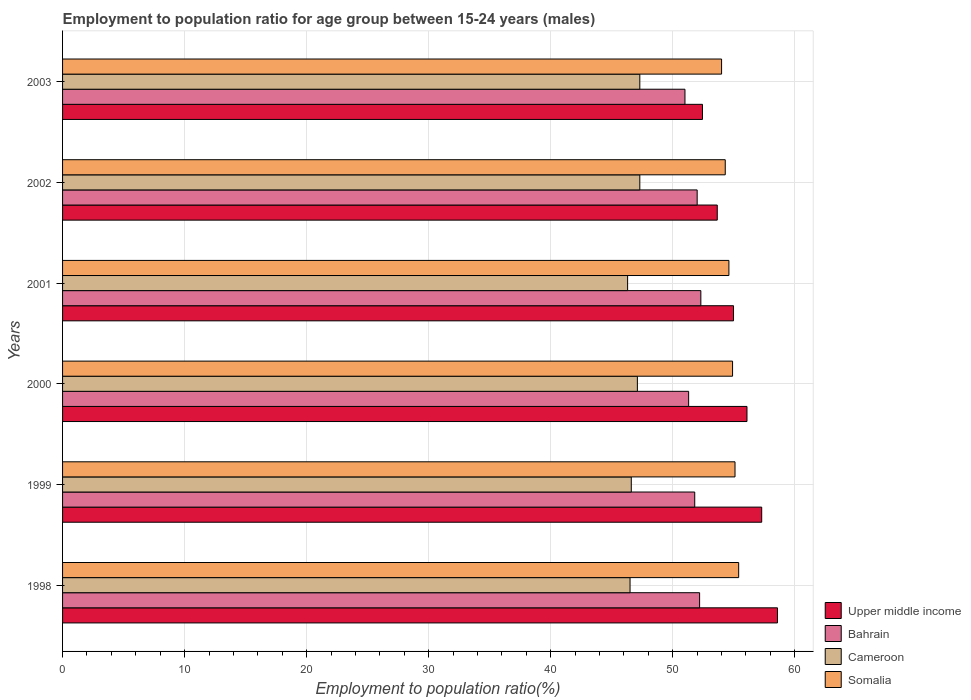How many different coloured bars are there?
Provide a short and direct response. 4. How many groups of bars are there?
Ensure brevity in your answer.  6. Are the number of bars per tick equal to the number of legend labels?
Your answer should be very brief. Yes. Are the number of bars on each tick of the Y-axis equal?
Your response must be concise. Yes. How many bars are there on the 6th tick from the bottom?
Give a very brief answer. 4. Across all years, what is the maximum employment to population ratio in Upper middle income?
Make the answer very short. 58.58. Across all years, what is the minimum employment to population ratio in Cameroon?
Offer a terse response. 46.3. In which year was the employment to population ratio in Somalia maximum?
Keep it short and to the point. 1998. What is the total employment to population ratio in Somalia in the graph?
Your answer should be compact. 328.3. What is the difference between the employment to population ratio in Upper middle income in 1998 and that in 1999?
Make the answer very short. 1.29. What is the difference between the employment to population ratio in Bahrain in 1998 and the employment to population ratio in Upper middle income in 1999?
Your answer should be compact. -5.09. What is the average employment to population ratio in Bahrain per year?
Make the answer very short. 51.77. What is the ratio of the employment to population ratio in Cameroon in 2000 to that in 2002?
Offer a very short reply. 1. Is the employment to population ratio in Bahrain in 1998 less than that in 2000?
Offer a terse response. No. Is the difference between the employment to population ratio in Somalia in 2001 and 2003 greater than the difference between the employment to population ratio in Bahrain in 2001 and 2003?
Offer a terse response. No. What is the difference between the highest and the second highest employment to population ratio in Somalia?
Offer a very short reply. 0.3. Is it the case that in every year, the sum of the employment to population ratio in Upper middle income and employment to population ratio in Cameroon is greater than the sum of employment to population ratio in Somalia and employment to population ratio in Bahrain?
Give a very brief answer. No. What does the 4th bar from the top in 2000 represents?
Offer a very short reply. Upper middle income. What does the 4th bar from the bottom in 2000 represents?
Your answer should be very brief. Somalia. Are all the bars in the graph horizontal?
Your response must be concise. Yes. How many years are there in the graph?
Your answer should be compact. 6. Are the values on the major ticks of X-axis written in scientific E-notation?
Keep it short and to the point. No. Does the graph contain any zero values?
Ensure brevity in your answer.  No. Does the graph contain grids?
Provide a succinct answer. Yes. Where does the legend appear in the graph?
Your answer should be compact. Bottom right. How many legend labels are there?
Provide a short and direct response. 4. What is the title of the graph?
Ensure brevity in your answer.  Employment to population ratio for age group between 15-24 years (males). What is the Employment to population ratio(%) in Upper middle income in 1998?
Provide a succinct answer. 58.58. What is the Employment to population ratio(%) in Bahrain in 1998?
Provide a succinct answer. 52.2. What is the Employment to population ratio(%) of Cameroon in 1998?
Your answer should be compact. 46.5. What is the Employment to population ratio(%) of Somalia in 1998?
Offer a very short reply. 55.4. What is the Employment to population ratio(%) in Upper middle income in 1999?
Offer a very short reply. 57.29. What is the Employment to population ratio(%) of Bahrain in 1999?
Offer a very short reply. 51.8. What is the Employment to population ratio(%) of Cameroon in 1999?
Make the answer very short. 46.6. What is the Employment to population ratio(%) of Somalia in 1999?
Your response must be concise. 55.1. What is the Employment to population ratio(%) in Upper middle income in 2000?
Offer a terse response. 56.08. What is the Employment to population ratio(%) in Bahrain in 2000?
Make the answer very short. 51.3. What is the Employment to population ratio(%) of Cameroon in 2000?
Keep it short and to the point. 47.1. What is the Employment to population ratio(%) of Somalia in 2000?
Your answer should be very brief. 54.9. What is the Employment to population ratio(%) in Upper middle income in 2001?
Your answer should be compact. 54.98. What is the Employment to population ratio(%) in Bahrain in 2001?
Offer a very short reply. 52.3. What is the Employment to population ratio(%) in Cameroon in 2001?
Offer a terse response. 46.3. What is the Employment to population ratio(%) of Somalia in 2001?
Offer a very short reply. 54.6. What is the Employment to population ratio(%) of Upper middle income in 2002?
Your answer should be very brief. 53.65. What is the Employment to population ratio(%) in Cameroon in 2002?
Your response must be concise. 47.3. What is the Employment to population ratio(%) of Somalia in 2002?
Provide a succinct answer. 54.3. What is the Employment to population ratio(%) of Upper middle income in 2003?
Offer a terse response. 52.43. What is the Employment to population ratio(%) in Cameroon in 2003?
Your answer should be very brief. 47.3. Across all years, what is the maximum Employment to population ratio(%) of Upper middle income?
Make the answer very short. 58.58. Across all years, what is the maximum Employment to population ratio(%) in Bahrain?
Provide a short and direct response. 52.3. Across all years, what is the maximum Employment to population ratio(%) in Cameroon?
Provide a short and direct response. 47.3. Across all years, what is the maximum Employment to population ratio(%) in Somalia?
Provide a succinct answer. 55.4. Across all years, what is the minimum Employment to population ratio(%) of Upper middle income?
Your answer should be compact. 52.43. Across all years, what is the minimum Employment to population ratio(%) in Bahrain?
Your response must be concise. 51. Across all years, what is the minimum Employment to population ratio(%) in Cameroon?
Provide a short and direct response. 46.3. What is the total Employment to population ratio(%) of Upper middle income in the graph?
Keep it short and to the point. 333.01. What is the total Employment to population ratio(%) of Bahrain in the graph?
Make the answer very short. 310.6. What is the total Employment to population ratio(%) of Cameroon in the graph?
Ensure brevity in your answer.  281.1. What is the total Employment to population ratio(%) of Somalia in the graph?
Offer a terse response. 328.3. What is the difference between the Employment to population ratio(%) of Upper middle income in 1998 and that in 1999?
Provide a succinct answer. 1.29. What is the difference between the Employment to population ratio(%) of Bahrain in 1998 and that in 1999?
Your response must be concise. 0.4. What is the difference between the Employment to population ratio(%) in Cameroon in 1998 and that in 1999?
Provide a short and direct response. -0.1. What is the difference between the Employment to population ratio(%) in Upper middle income in 1998 and that in 2000?
Make the answer very short. 2.5. What is the difference between the Employment to population ratio(%) in Bahrain in 1998 and that in 2000?
Provide a short and direct response. 0.9. What is the difference between the Employment to population ratio(%) of Upper middle income in 1998 and that in 2001?
Make the answer very short. 3.6. What is the difference between the Employment to population ratio(%) of Cameroon in 1998 and that in 2001?
Your answer should be very brief. 0.2. What is the difference between the Employment to population ratio(%) in Upper middle income in 1998 and that in 2002?
Make the answer very short. 4.93. What is the difference between the Employment to population ratio(%) in Bahrain in 1998 and that in 2002?
Offer a very short reply. 0.2. What is the difference between the Employment to population ratio(%) of Cameroon in 1998 and that in 2002?
Your answer should be very brief. -0.8. What is the difference between the Employment to population ratio(%) in Somalia in 1998 and that in 2002?
Provide a succinct answer. 1.1. What is the difference between the Employment to population ratio(%) of Upper middle income in 1998 and that in 2003?
Provide a succinct answer. 6.14. What is the difference between the Employment to population ratio(%) of Cameroon in 1998 and that in 2003?
Give a very brief answer. -0.8. What is the difference between the Employment to population ratio(%) of Somalia in 1998 and that in 2003?
Provide a short and direct response. 1.4. What is the difference between the Employment to population ratio(%) in Upper middle income in 1999 and that in 2000?
Keep it short and to the point. 1.21. What is the difference between the Employment to population ratio(%) in Cameroon in 1999 and that in 2000?
Your answer should be very brief. -0.5. What is the difference between the Employment to population ratio(%) of Somalia in 1999 and that in 2000?
Provide a succinct answer. 0.2. What is the difference between the Employment to population ratio(%) in Upper middle income in 1999 and that in 2001?
Ensure brevity in your answer.  2.31. What is the difference between the Employment to population ratio(%) in Cameroon in 1999 and that in 2001?
Your response must be concise. 0.3. What is the difference between the Employment to population ratio(%) of Somalia in 1999 and that in 2001?
Keep it short and to the point. 0.5. What is the difference between the Employment to population ratio(%) of Upper middle income in 1999 and that in 2002?
Offer a terse response. 3.64. What is the difference between the Employment to population ratio(%) in Bahrain in 1999 and that in 2002?
Your answer should be compact. -0.2. What is the difference between the Employment to population ratio(%) in Cameroon in 1999 and that in 2002?
Your answer should be compact. -0.7. What is the difference between the Employment to population ratio(%) in Upper middle income in 1999 and that in 2003?
Ensure brevity in your answer.  4.85. What is the difference between the Employment to population ratio(%) of Somalia in 1999 and that in 2003?
Provide a succinct answer. 1.1. What is the difference between the Employment to population ratio(%) in Upper middle income in 2000 and that in 2001?
Give a very brief answer. 1.1. What is the difference between the Employment to population ratio(%) in Cameroon in 2000 and that in 2001?
Your response must be concise. 0.8. What is the difference between the Employment to population ratio(%) in Upper middle income in 2000 and that in 2002?
Your answer should be compact. 2.44. What is the difference between the Employment to population ratio(%) of Cameroon in 2000 and that in 2002?
Provide a short and direct response. -0.2. What is the difference between the Employment to population ratio(%) of Somalia in 2000 and that in 2002?
Offer a terse response. 0.6. What is the difference between the Employment to population ratio(%) in Upper middle income in 2000 and that in 2003?
Your answer should be compact. 3.65. What is the difference between the Employment to population ratio(%) in Cameroon in 2000 and that in 2003?
Your response must be concise. -0.2. What is the difference between the Employment to population ratio(%) of Somalia in 2000 and that in 2003?
Provide a short and direct response. 0.9. What is the difference between the Employment to population ratio(%) of Upper middle income in 2001 and that in 2002?
Ensure brevity in your answer.  1.33. What is the difference between the Employment to population ratio(%) in Bahrain in 2001 and that in 2002?
Your answer should be very brief. 0.3. What is the difference between the Employment to population ratio(%) in Upper middle income in 2001 and that in 2003?
Keep it short and to the point. 2.54. What is the difference between the Employment to population ratio(%) in Cameroon in 2001 and that in 2003?
Make the answer very short. -1. What is the difference between the Employment to population ratio(%) of Upper middle income in 2002 and that in 2003?
Make the answer very short. 1.21. What is the difference between the Employment to population ratio(%) of Cameroon in 2002 and that in 2003?
Your response must be concise. 0. What is the difference between the Employment to population ratio(%) of Upper middle income in 1998 and the Employment to population ratio(%) of Bahrain in 1999?
Offer a very short reply. 6.78. What is the difference between the Employment to population ratio(%) in Upper middle income in 1998 and the Employment to population ratio(%) in Cameroon in 1999?
Ensure brevity in your answer.  11.98. What is the difference between the Employment to population ratio(%) in Upper middle income in 1998 and the Employment to population ratio(%) in Somalia in 1999?
Keep it short and to the point. 3.48. What is the difference between the Employment to population ratio(%) in Bahrain in 1998 and the Employment to population ratio(%) in Cameroon in 1999?
Offer a terse response. 5.6. What is the difference between the Employment to population ratio(%) of Bahrain in 1998 and the Employment to population ratio(%) of Somalia in 1999?
Provide a short and direct response. -2.9. What is the difference between the Employment to population ratio(%) of Cameroon in 1998 and the Employment to population ratio(%) of Somalia in 1999?
Your answer should be compact. -8.6. What is the difference between the Employment to population ratio(%) of Upper middle income in 1998 and the Employment to population ratio(%) of Bahrain in 2000?
Your answer should be compact. 7.28. What is the difference between the Employment to population ratio(%) in Upper middle income in 1998 and the Employment to population ratio(%) in Cameroon in 2000?
Provide a succinct answer. 11.48. What is the difference between the Employment to population ratio(%) of Upper middle income in 1998 and the Employment to population ratio(%) of Somalia in 2000?
Provide a succinct answer. 3.68. What is the difference between the Employment to population ratio(%) in Bahrain in 1998 and the Employment to population ratio(%) in Cameroon in 2000?
Offer a very short reply. 5.1. What is the difference between the Employment to population ratio(%) in Bahrain in 1998 and the Employment to population ratio(%) in Somalia in 2000?
Your answer should be compact. -2.7. What is the difference between the Employment to population ratio(%) in Upper middle income in 1998 and the Employment to population ratio(%) in Bahrain in 2001?
Offer a terse response. 6.28. What is the difference between the Employment to population ratio(%) in Upper middle income in 1998 and the Employment to population ratio(%) in Cameroon in 2001?
Ensure brevity in your answer.  12.28. What is the difference between the Employment to population ratio(%) in Upper middle income in 1998 and the Employment to population ratio(%) in Somalia in 2001?
Make the answer very short. 3.98. What is the difference between the Employment to population ratio(%) of Upper middle income in 1998 and the Employment to population ratio(%) of Bahrain in 2002?
Give a very brief answer. 6.58. What is the difference between the Employment to population ratio(%) in Upper middle income in 1998 and the Employment to population ratio(%) in Cameroon in 2002?
Provide a short and direct response. 11.28. What is the difference between the Employment to population ratio(%) of Upper middle income in 1998 and the Employment to population ratio(%) of Somalia in 2002?
Offer a very short reply. 4.28. What is the difference between the Employment to population ratio(%) of Bahrain in 1998 and the Employment to population ratio(%) of Somalia in 2002?
Make the answer very short. -2.1. What is the difference between the Employment to population ratio(%) in Cameroon in 1998 and the Employment to population ratio(%) in Somalia in 2002?
Provide a succinct answer. -7.8. What is the difference between the Employment to population ratio(%) in Upper middle income in 1998 and the Employment to population ratio(%) in Bahrain in 2003?
Keep it short and to the point. 7.58. What is the difference between the Employment to population ratio(%) in Upper middle income in 1998 and the Employment to population ratio(%) in Cameroon in 2003?
Your answer should be very brief. 11.28. What is the difference between the Employment to population ratio(%) in Upper middle income in 1998 and the Employment to population ratio(%) in Somalia in 2003?
Provide a short and direct response. 4.58. What is the difference between the Employment to population ratio(%) of Upper middle income in 1999 and the Employment to population ratio(%) of Bahrain in 2000?
Make the answer very short. 5.99. What is the difference between the Employment to population ratio(%) in Upper middle income in 1999 and the Employment to population ratio(%) in Cameroon in 2000?
Your answer should be compact. 10.19. What is the difference between the Employment to population ratio(%) in Upper middle income in 1999 and the Employment to population ratio(%) in Somalia in 2000?
Provide a short and direct response. 2.39. What is the difference between the Employment to population ratio(%) of Bahrain in 1999 and the Employment to population ratio(%) of Cameroon in 2000?
Offer a terse response. 4.7. What is the difference between the Employment to population ratio(%) of Bahrain in 1999 and the Employment to population ratio(%) of Somalia in 2000?
Make the answer very short. -3.1. What is the difference between the Employment to population ratio(%) in Upper middle income in 1999 and the Employment to population ratio(%) in Bahrain in 2001?
Make the answer very short. 4.99. What is the difference between the Employment to population ratio(%) of Upper middle income in 1999 and the Employment to population ratio(%) of Cameroon in 2001?
Offer a very short reply. 10.99. What is the difference between the Employment to population ratio(%) of Upper middle income in 1999 and the Employment to population ratio(%) of Somalia in 2001?
Your answer should be very brief. 2.69. What is the difference between the Employment to population ratio(%) of Upper middle income in 1999 and the Employment to population ratio(%) of Bahrain in 2002?
Offer a very short reply. 5.29. What is the difference between the Employment to population ratio(%) of Upper middle income in 1999 and the Employment to population ratio(%) of Cameroon in 2002?
Make the answer very short. 9.99. What is the difference between the Employment to population ratio(%) in Upper middle income in 1999 and the Employment to population ratio(%) in Somalia in 2002?
Your response must be concise. 2.99. What is the difference between the Employment to population ratio(%) in Cameroon in 1999 and the Employment to population ratio(%) in Somalia in 2002?
Ensure brevity in your answer.  -7.7. What is the difference between the Employment to population ratio(%) in Upper middle income in 1999 and the Employment to population ratio(%) in Bahrain in 2003?
Offer a terse response. 6.29. What is the difference between the Employment to population ratio(%) of Upper middle income in 1999 and the Employment to population ratio(%) of Cameroon in 2003?
Your response must be concise. 9.99. What is the difference between the Employment to population ratio(%) of Upper middle income in 1999 and the Employment to population ratio(%) of Somalia in 2003?
Offer a very short reply. 3.29. What is the difference between the Employment to population ratio(%) in Bahrain in 1999 and the Employment to population ratio(%) in Somalia in 2003?
Ensure brevity in your answer.  -2.2. What is the difference between the Employment to population ratio(%) of Cameroon in 1999 and the Employment to population ratio(%) of Somalia in 2003?
Give a very brief answer. -7.4. What is the difference between the Employment to population ratio(%) in Upper middle income in 2000 and the Employment to population ratio(%) in Bahrain in 2001?
Ensure brevity in your answer.  3.78. What is the difference between the Employment to population ratio(%) in Upper middle income in 2000 and the Employment to population ratio(%) in Cameroon in 2001?
Give a very brief answer. 9.78. What is the difference between the Employment to population ratio(%) of Upper middle income in 2000 and the Employment to population ratio(%) of Somalia in 2001?
Your answer should be very brief. 1.48. What is the difference between the Employment to population ratio(%) of Bahrain in 2000 and the Employment to population ratio(%) of Somalia in 2001?
Provide a short and direct response. -3.3. What is the difference between the Employment to population ratio(%) of Upper middle income in 2000 and the Employment to population ratio(%) of Bahrain in 2002?
Provide a short and direct response. 4.08. What is the difference between the Employment to population ratio(%) in Upper middle income in 2000 and the Employment to population ratio(%) in Cameroon in 2002?
Ensure brevity in your answer.  8.78. What is the difference between the Employment to population ratio(%) of Upper middle income in 2000 and the Employment to population ratio(%) of Somalia in 2002?
Provide a succinct answer. 1.78. What is the difference between the Employment to population ratio(%) in Bahrain in 2000 and the Employment to population ratio(%) in Somalia in 2002?
Provide a succinct answer. -3. What is the difference between the Employment to population ratio(%) of Upper middle income in 2000 and the Employment to population ratio(%) of Bahrain in 2003?
Keep it short and to the point. 5.08. What is the difference between the Employment to population ratio(%) of Upper middle income in 2000 and the Employment to population ratio(%) of Cameroon in 2003?
Offer a terse response. 8.78. What is the difference between the Employment to population ratio(%) of Upper middle income in 2000 and the Employment to population ratio(%) of Somalia in 2003?
Ensure brevity in your answer.  2.08. What is the difference between the Employment to population ratio(%) of Bahrain in 2000 and the Employment to population ratio(%) of Somalia in 2003?
Your answer should be compact. -2.7. What is the difference between the Employment to population ratio(%) of Cameroon in 2000 and the Employment to population ratio(%) of Somalia in 2003?
Offer a terse response. -6.9. What is the difference between the Employment to population ratio(%) of Upper middle income in 2001 and the Employment to population ratio(%) of Bahrain in 2002?
Give a very brief answer. 2.98. What is the difference between the Employment to population ratio(%) in Upper middle income in 2001 and the Employment to population ratio(%) in Cameroon in 2002?
Offer a very short reply. 7.68. What is the difference between the Employment to population ratio(%) of Upper middle income in 2001 and the Employment to population ratio(%) of Somalia in 2002?
Provide a short and direct response. 0.68. What is the difference between the Employment to population ratio(%) in Bahrain in 2001 and the Employment to population ratio(%) in Cameroon in 2002?
Offer a very short reply. 5. What is the difference between the Employment to population ratio(%) of Bahrain in 2001 and the Employment to population ratio(%) of Somalia in 2002?
Ensure brevity in your answer.  -2. What is the difference between the Employment to population ratio(%) in Cameroon in 2001 and the Employment to population ratio(%) in Somalia in 2002?
Make the answer very short. -8. What is the difference between the Employment to population ratio(%) in Upper middle income in 2001 and the Employment to population ratio(%) in Bahrain in 2003?
Make the answer very short. 3.98. What is the difference between the Employment to population ratio(%) of Upper middle income in 2001 and the Employment to population ratio(%) of Cameroon in 2003?
Ensure brevity in your answer.  7.68. What is the difference between the Employment to population ratio(%) of Upper middle income in 2001 and the Employment to population ratio(%) of Somalia in 2003?
Give a very brief answer. 0.98. What is the difference between the Employment to population ratio(%) in Bahrain in 2001 and the Employment to population ratio(%) in Cameroon in 2003?
Keep it short and to the point. 5. What is the difference between the Employment to population ratio(%) of Bahrain in 2001 and the Employment to population ratio(%) of Somalia in 2003?
Your response must be concise. -1.7. What is the difference between the Employment to population ratio(%) of Upper middle income in 2002 and the Employment to population ratio(%) of Bahrain in 2003?
Your response must be concise. 2.65. What is the difference between the Employment to population ratio(%) in Upper middle income in 2002 and the Employment to population ratio(%) in Cameroon in 2003?
Offer a terse response. 6.35. What is the difference between the Employment to population ratio(%) of Upper middle income in 2002 and the Employment to population ratio(%) of Somalia in 2003?
Your answer should be compact. -0.35. What is the difference between the Employment to population ratio(%) in Bahrain in 2002 and the Employment to population ratio(%) in Somalia in 2003?
Offer a very short reply. -2. What is the average Employment to population ratio(%) of Upper middle income per year?
Offer a terse response. 55.5. What is the average Employment to population ratio(%) in Bahrain per year?
Your answer should be compact. 51.77. What is the average Employment to population ratio(%) in Cameroon per year?
Make the answer very short. 46.85. What is the average Employment to population ratio(%) of Somalia per year?
Keep it short and to the point. 54.72. In the year 1998, what is the difference between the Employment to population ratio(%) of Upper middle income and Employment to population ratio(%) of Bahrain?
Give a very brief answer. 6.38. In the year 1998, what is the difference between the Employment to population ratio(%) of Upper middle income and Employment to population ratio(%) of Cameroon?
Provide a short and direct response. 12.08. In the year 1998, what is the difference between the Employment to population ratio(%) in Upper middle income and Employment to population ratio(%) in Somalia?
Provide a short and direct response. 3.18. In the year 1998, what is the difference between the Employment to population ratio(%) of Bahrain and Employment to population ratio(%) of Cameroon?
Provide a short and direct response. 5.7. In the year 1998, what is the difference between the Employment to population ratio(%) of Cameroon and Employment to population ratio(%) of Somalia?
Give a very brief answer. -8.9. In the year 1999, what is the difference between the Employment to population ratio(%) in Upper middle income and Employment to population ratio(%) in Bahrain?
Give a very brief answer. 5.49. In the year 1999, what is the difference between the Employment to population ratio(%) of Upper middle income and Employment to population ratio(%) of Cameroon?
Provide a short and direct response. 10.69. In the year 1999, what is the difference between the Employment to population ratio(%) in Upper middle income and Employment to population ratio(%) in Somalia?
Your answer should be very brief. 2.19. In the year 1999, what is the difference between the Employment to population ratio(%) in Bahrain and Employment to population ratio(%) in Cameroon?
Your response must be concise. 5.2. In the year 1999, what is the difference between the Employment to population ratio(%) in Cameroon and Employment to population ratio(%) in Somalia?
Offer a terse response. -8.5. In the year 2000, what is the difference between the Employment to population ratio(%) of Upper middle income and Employment to population ratio(%) of Bahrain?
Keep it short and to the point. 4.78. In the year 2000, what is the difference between the Employment to population ratio(%) of Upper middle income and Employment to population ratio(%) of Cameroon?
Make the answer very short. 8.98. In the year 2000, what is the difference between the Employment to population ratio(%) in Upper middle income and Employment to population ratio(%) in Somalia?
Your answer should be compact. 1.18. In the year 2000, what is the difference between the Employment to population ratio(%) in Cameroon and Employment to population ratio(%) in Somalia?
Your answer should be compact. -7.8. In the year 2001, what is the difference between the Employment to population ratio(%) in Upper middle income and Employment to population ratio(%) in Bahrain?
Ensure brevity in your answer.  2.68. In the year 2001, what is the difference between the Employment to population ratio(%) in Upper middle income and Employment to population ratio(%) in Cameroon?
Offer a terse response. 8.68. In the year 2001, what is the difference between the Employment to population ratio(%) of Upper middle income and Employment to population ratio(%) of Somalia?
Offer a terse response. 0.38. In the year 2002, what is the difference between the Employment to population ratio(%) of Upper middle income and Employment to population ratio(%) of Bahrain?
Make the answer very short. 1.65. In the year 2002, what is the difference between the Employment to population ratio(%) in Upper middle income and Employment to population ratio(%) in Cameroon?
Ensure brevity in your answer.  6.35. In the year 2002, what is the difference between the Employment to population ratio(%) in Upper middle income and Employment to population ratio(%) in Somalia?
Offer a terse response. -0.65. In the year 2002, what is the difference between the Employment to population ratio(%) in Bahrain and Employment to population ratio(%) in Cameroon?
Ensure brevity in your answer.  4.7. In the year 2002, what is the difference between the Employment to population ratio(%) in Bahrain and Employment to population ratio(%) in Somalia?
Your answer should be very brief. -2.3. In the year 2003, what is the difference between the Employment to population ratio(%) in Upper middle income and Employment to population ratio(%) in Bahrain?
Give a very brief answer. 1.43. In the year 2003, what is the difference between the Employment to population ratio(%) of Upper middle income and Employment to population ratio(%) of Cameroon?
Provide a short and direct response. 5.13. In the year 2003, what is the difference between the Employment to population ratio(%) in Upper middle income and Employment to population ratio(%) in Somalia?
Offer a terse response. -1.57. What is the ratio of the Employment to population ratio(%) of Upper middle income in 1998 to that in 1999?
Give a very brief answer. 1.02. What is the ratio of the Employment to population ratio(%) of Bahrain in 1998 to that in 1999?
Give a very brief answer. 1.01. What is the ratio of the Employment to population ratio(%) in Somalia in 1998 to that in 1999?
Give a very brief answer. 1.01. What is the ratio of the Employment to population ratio(%) of Upper middle income in 1998 to that in 2000?
Give a very brief answer. 1.04. What is the ratio of the Employment to population ratio(%) of Bahrain in 1998 to that in 2000?
Offer a terse response. 1.02. What is the ratio of the Employment to population ratio(%) of Cameroon in 1998 to that in 2000?
Offer a very short reply. 0.99. What is the ratio of the Employment to population ratio(%) in Somalia in 1998 to that in 2000?
Your answer should be compact. 1.01. What is the ratio of the Employment to population ratio(%) in Upper middle income in 1998 to that in 2001?
Your answer should be very brief. 1.07. What is the ratio of the Employment to population ratio(%) of Bahrain in 1998 to that in 2001?
Provide a succinct answer. 1. What is the ratio of the Employment to population ratio(%) in Cameroon in 1998 to that in 2001?
Give a very brief answer. 1. What is the ratio of the Employment to population ratio(%) in Somalia in 1998 to that in 2001?
Ensure brevity in your answer.  1.01. What is the ratio of the Employment to population ratio(%) in Upper middle income in 1998 to that in 2002?
Offer a very short reply. 1.09. What is the ratio of the Employment to population ratio(%) in Cameroon in 1998 to that in 2002?
Provide a succinct answer. 0.98. What is the ratio of the Employment to population ratio(%) of Somalia in 1998 to that in 2002?
Your answer should be compact. 1.02. What is the ratio of the Employment to population ratio(%) in Upper middle income in 1998 to that in 2003?
Your answer should be very brief. 1.12. What is the ratio of the Employment to population ratio(%) in Bahrain in 1998 to that in 2003?
Your answer should be very brief. 1.02. What is the ratio of the Employment to population ratio(%) of Cameroon in 1998 to that in 2003?
Ensure brevity in your answer.  0.98. What is the ratio of the Employment to population ratio(%) of Somalia in 1998 to that in 2003?
Your answer should be compact. 1.03. What is the ratio of the Employment to population ratio(%) of Upper middle income in 1999 to that in 2000?
Ensure brevity in your answer.  1.02. What is the ratio of the Employment to population ratio(%) in Bahrain in 1999 to that in 2000?
Your answer should be compact. 1.01. What is the ratio of the Employment to population ratio(%) in Somalia in 1999 to that in 2000?
Give a very brief answer. 1. What is the ratio of the Employment to population ratio(%) of Upper middle income in 1999 to that in 2001?
Your answer should be very brief. 1.04. What is the ratio of the Employment to population ratio(%) in Somalia in 1999 to that in 2001?
Provide a short and direct response. 1.01. What is the ratio of the Employment to population ratio(%) in Upper middle income in 1999 to that in 2002?
Provide a succinct answer. 1.07. What is the ratio of the Employment to population ratio(%) in Bahrain in 1999 to that in 2002?
Your answer should be compact. 1. What is the ratio of the Employment to population ratio(%) of Cameroon in 1999 to that in 2002?
Your response must be concise. 0.99. What is the ratio of the Employment to population ratio(%) of Somalia in 1999 to that in 2002?
Offer a very short reply. 1.01. What is the ratio of the Employment to population ratio(%) of Upper middle income in 1999 to that in 2003?
Provide a succinct answer. 1.09. What is the ratio of the Employment to population ratio(%) in Bahrain in 1999 to that in 2003?
Provide a short and direct response. 1.02. What is the ratio of the Employment to population ratio(%) of Cameroon in 1999 to that in 2003?
Ensure brevity in your answer.  0.99. What is the ratio of the Employment to population ratio(%) in Somalia in 1999 to that in 2003?
Your response must be concise. 1.02. What is the ratio of the Employment to population ratio(%) in Upper middle income in 2000 to that in 2001?
Give a very brief answer. 1.02. What is the ratio of the Employment to population ratio(%) in Bahrain in 2000 to that in 2001?
Keep it short and to the point. 0.98. What is the ratio of the Employment to population ratio(%) in Cameroon in 2000 to that in 2001?
Provide a succinct answer. 1.02. What is the ratio of the Employment to population ratio(%) of Upper middle income in 2000 to that in 2002?
Provide a short and direct response. 1.05. What is the ratio of the Employment to population ratio(%) in Bahrain in 2000 to that in 2002?
Ensure brevity in your answer.  0.99. What is the ratio of the Employment to population ratio(%) of Somalia in 2000 to that in 2002?
Offer a terse response. 1.01. What is the ratio of the Employment to population ratio(%) of Upper middle income in 2000 to that in 2003?
Make the answer very short. 1.07. What is the ratio of the Employment to population ratio(%) in Bahrain in 2000 to that in 2003?
Provide a short and direct response. 1.01. What is the ratio of the Employment to population ratio(%) of Somalia in 2000 to that in 2003?
Offer a very short reply. 1.02. What is the ratio of the Employment to population ratio(%) in Upper middle income in 2001 to that in 2002?
Keep it short and to the point. 1.02. What is the ratio of the Employment to population ratio(%) in Bahrain in 2001 to that in 2002?
Your response must be concise. 1.01. What is the ratio of the Employment to population ratio(%) in Cameroon in 2001 to that in 2002?
Make the answer very short. 0.98. What is the ratio of the Employment to population ratio(%) of Somalia in 2001 to that in 2002?
Your answer should be compact. 1.01. What is the ratio of the Employment to population ratio(%) in Upper middle income in 2001 to that in 2003?
Keep it short and to the point. 1.05. What is the ratio of the Employment to population ratio(%) in Bahrain in 2001 to that in 2003?
Ensure brevity in your answer.  1.03. What is the ratio of the Employment to population ratio(%) of Cameroon in 2001 to that in 2003?
Offer a very short reply. 0.98. What is the ratio of the Employment to population ratio(%) in Somalia in 2001 to that in 2003?
Keep it short and to the point. 1.01. What is the ratio of the Employment to population ratio(%) of Upper middle income in 2002 to that in 2003?
Make the answer very short. 1.02. What is the ratio of the Employment to population ratio(%) of Bahrain in 2002 to that in 2003?
Your answer should be compact. 1.02. What is the ratio of the Employment to population ratio(%) of Cameroon in 2002 to that in 2003?
Provide a short and direct response. 1. What is the ratio of the Employment to population ratio(%) of Somalia in 2002 to that in 2003?
Your response must be concise. 1.01. What is the difference between the highest and the second highest Employment to population ratio(%) of Upper middle income?
Keep it short and to the point. 1.29. What is the difference between the highest and the second highest Employment to population ratio(%) of Bahrain?
Provide a short and direct response. 0.1. What is the difference between the highest and the lowest Employment to population ratio(%) in Upper middle income?
Provide a succinct answer. 6.14. 